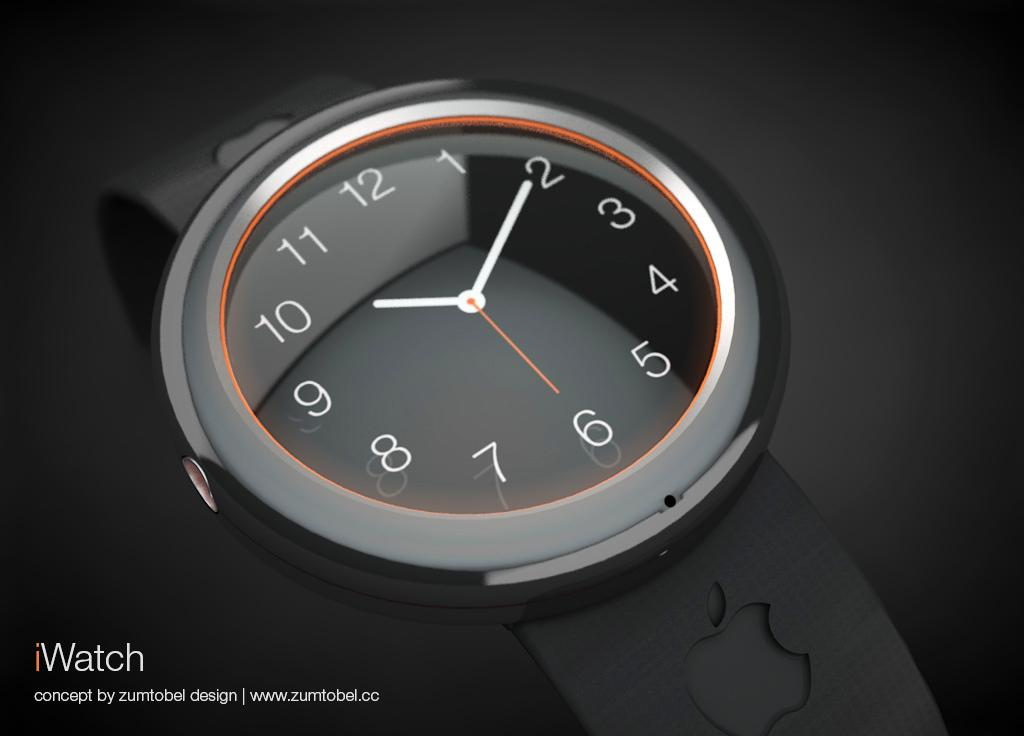<image>
Create a compact narrative representing the image presented. A watch with a black face is seen with an iWatch logo in the corner. 